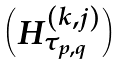Convert formula to latex. <formula><loc_0><loc_0><loc_500><loc_500>\begin{pmatrix} H ^ { ( k , j ) } _ { \tau _ { p , q } } \end{pmatrix}</formula> 